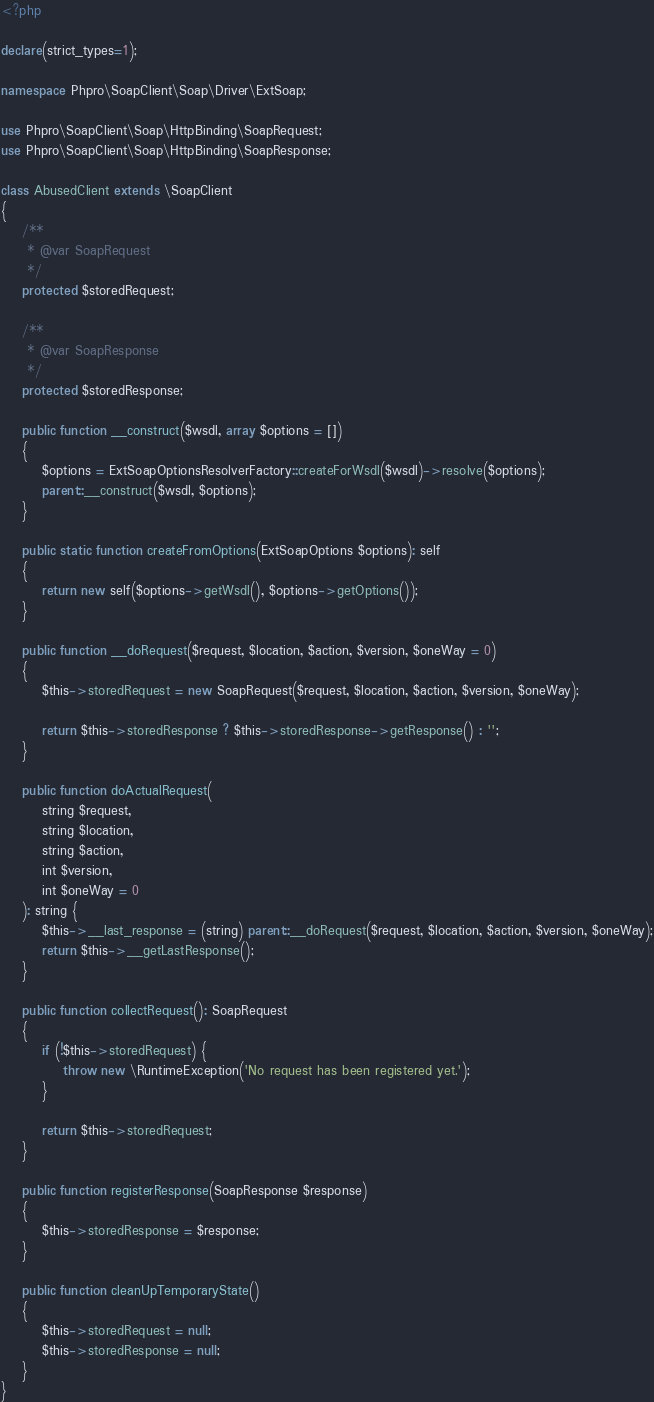<code> <loc_0><loc_0><loc_500><loc_500><_PHP_><?php

declare(strict_types=1);

namespace Phpro\SoapClient\Soap\Driver\ExtSoap;

use Phpro\SoapClient\Soap\HttpBinding\SoapRequest;
use Phpro\SoapClient\Soap\HttpBinding\SoapResponse;

class AbusedClient extends \SoapClient
{
    /**
     * @var SoapRequest
     */
    protected $storedRequest;

    /**
     * @var SoapResponse
     */
    protected $storedResponse;

    public function __construct($wsdl, array $options = [])
    {
        $options = ExtSoapOptionsResolverFactory::createForWsdl($wsdl)->resolve($options);
        parent::__construct($wsdl, $options);
    }

    public static function createFromOptions(ExtSoapOptions $options): self
    {
        return new self($options->getWsdl(), $options->getOptions());
    }

    public function __doRequest($request, $location, $action, $version, $oneWay = 0)
    {
        $this->storedRequest = new SoapRequest($request, $location, $action, $version, $oneWay);

        return $this->storedResponse ? $this->storedResponse->getResponse() : '';
    }

    public function doActualRequest(
        string $request,
        string $location,
        string $action,
        int $version,
        int $oneWay = 0
    ): string {
        $this->__last_response = (string) parent::__doRequest($request, $location, $action, $version, $oneWay);
        return $this->__getLastResponse();
    }

    public function collectRequest(): SoapRequest
    {
        if (!$this->storedRequest) {
            throw new \RuntimeException('No request has been registered yet.');
        }

        return $this->storedRequest;
    }

    public function registerResponse(SoapResponse $response)
    {
        $this->storedResponse = $response;
    }

    public function cleanUpTemporaryState()
    {
        $this->storedRequest = null;
        $this->storedResponse = null;
    }
}
</code> 